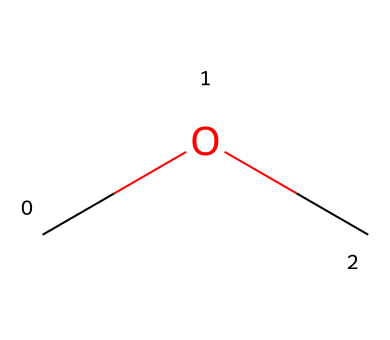What is the primary functional group in methoxymethane? The chemical structure shows an ether functional group, which is indicated by the oxygen (O) bonded between two carbon (C) atoms, characteristic of ethers.
Answer: ether How many carbon atoms are present in methoxymethane? The SMILES representation shows two carbon (C) atoms, one in each of the two methoxy (−O−CH3) groups in the structure.
Answer: two What type of bond exists between the oxygen and carbon atoms in methoxymethane? The bond between the oxygen and carbon atoms is a single bond (denoted by the connection without any number prefix or double bond in the SMILES).
Answer: single bond Is methoxymethane polar or nonpolar? The presence of the electronegative oxygen atom creates a slight dipole, suggesting that the molecule is polar, although it has nonpolar carbon-hydrogen bonds.
Answer: polar What is the common use of methoxymethane in medical applications? Methoxymethane is commonly used as a solvent or sterilizing agent in medical equipment for its ability to effectively dissolve other substances and its antimicrobial properties.
Answer: solvent How many hydrogen atoms are present in methoxymethane? There are six hydrogen (H) atoms in methoxymethane; there are three from each methoxy group and an additional hydrogen from the second carbon.
Answer: six 